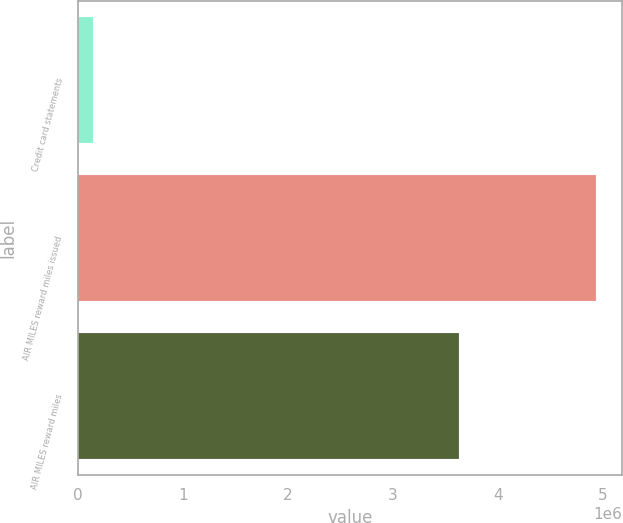Convert chart. <chart><loc_0><loc_0><loc_500><loc_500><bar_chart><fcel>Credit card statements<fcel>AIR MILES reward miles issued<fcel>AIR MILES reward miles<nl><fcel>142064<fcel>4.94036e+06<fcel>3.63392e+06<nl></chart> 